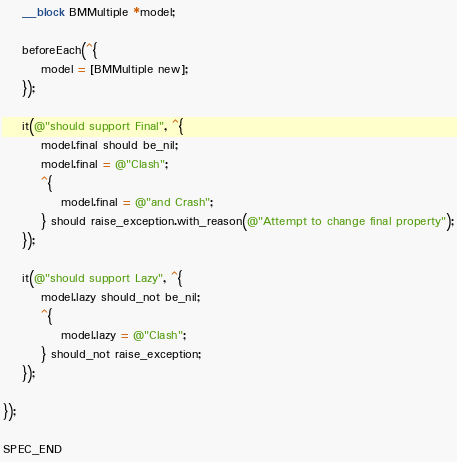Convert code to text. <code><loc_0><loc_0><loc_500><loc_500><_ObjectiveC_>    __block BMMultiple *model;

    beforeEach(^{
        model = [BMMultiple new];
    });
    
    it(@"should support Final", ^{
        model.final should be_nil;
        model.final = @"Clash";
        ^{
            model.final = @"and Crash";
        } should raise_exception.with_reason(@"Attempt to change final property");
    });
    
    it(@"should support Lazy", ^{
        model.lazy should_not be_nil;
        ^{
            model.lazy = @"Clash";
        } should_not raise_exception;
    });
    
});

SPEC_END
</code> 